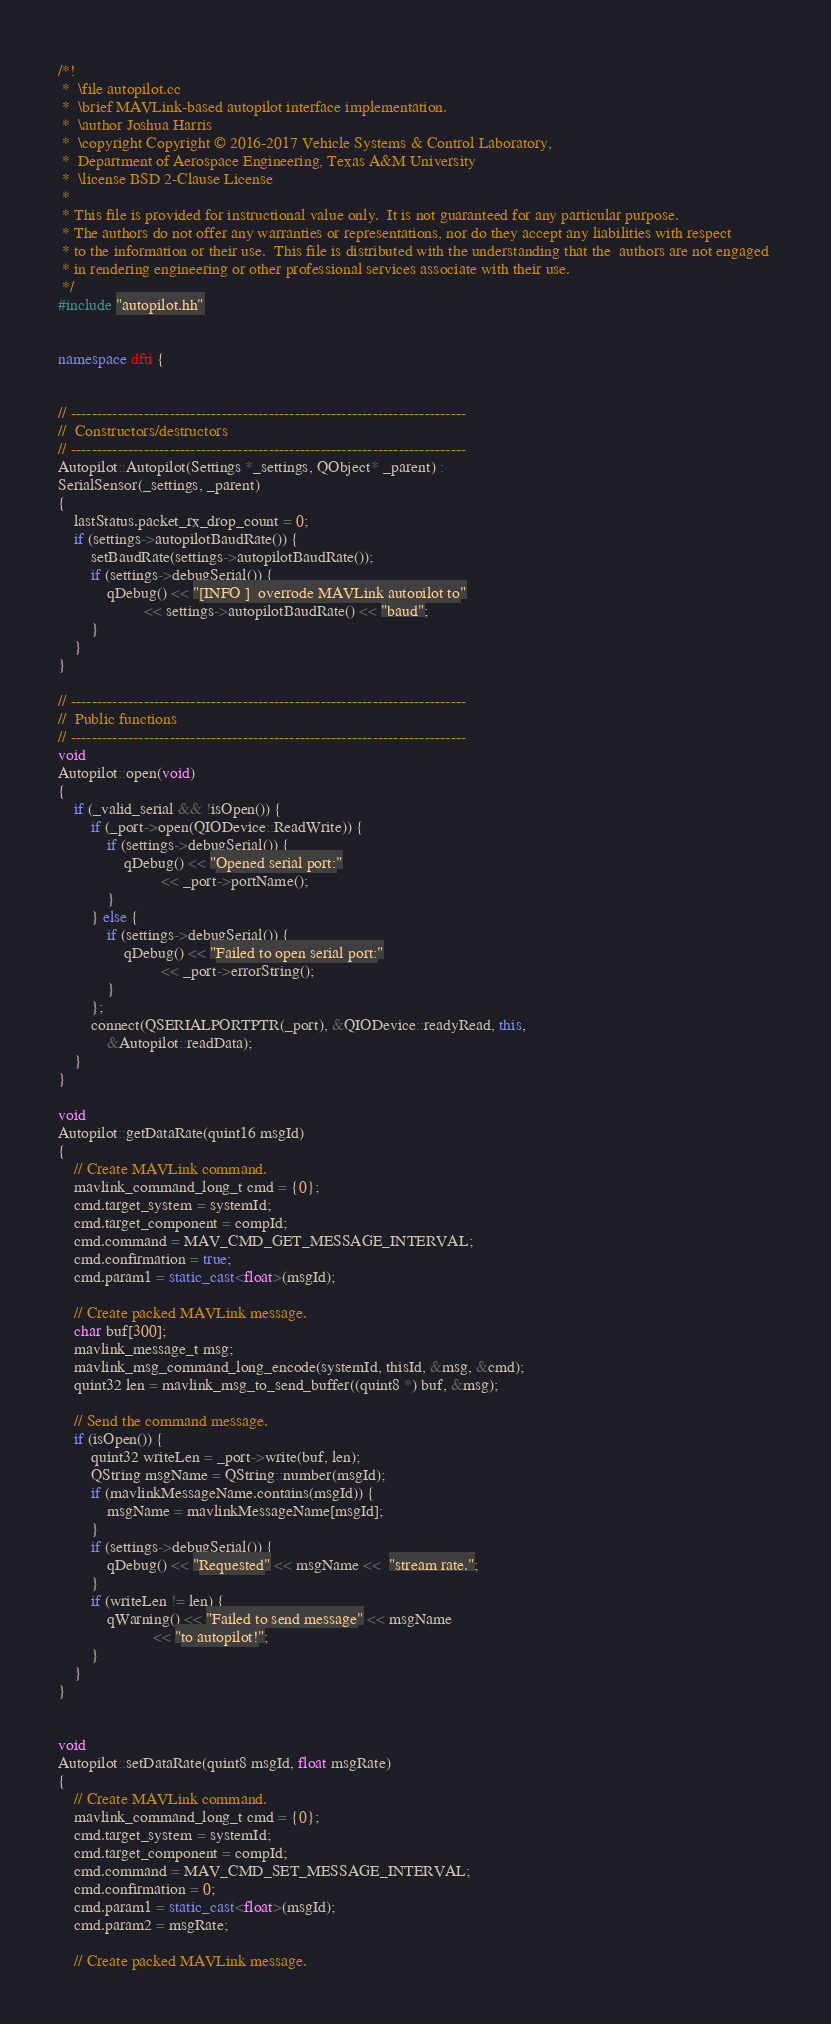Convert code to text. <code><loc_0><loc_0><loc_500><loc_500><_C++_>/*!
 *  \file autopilot.cc
 *  \brief MAVLink-based autopilot interface implementation.
 *  \author Joshua Harris
 *  \copyright Copyright © 2016-2017 Vehicle Systems & Control Laboratory,
 *  Department of Aerospace Engineering, Texas A&M University
 *  \license BSD 2-Clause License
 *
 * This file is provided for instructional value only.  It is not guaranteed for any particular purpose.  
 * The authors do not offer any warranties or representations, nor do they accept any liabilities with respect 
 * to the information or their use.  This file is distributed with the understanding that the  authors are not engaged 
 * in rendering engineering or other professional services associate with their use.
 */
#include "autopilot.hh"


namespace dfti {


// ----------------------------------------------------------------------------
//  Constructors/destructors
// ----------------------------------------------------------------------------
Autopilot::Autopilot(Settings *_settings, QObject* _parent) :
SerialSensor(_settings, _parent)
{
    lastStatus.packet_rx_drop_count = 0;
    if (settings->autopilotBaudRate()) {
        setBaudRate(settings->autopilotBaudRate());
        if (settings->debugSerial()) {
            qDebug() << "[INFO ]  overrode MAVLink autopilot to"
                     << settings->autopilotBaudRate() << "baud";
        }
    }
}

// ----------------------------------------------------------------------------
//  Public functions
// ----------------------------------------------------------------------------
void
Autopilot::open(void)
{
    if (_valid_serial && !isOpen()) {
        if (_port->open(QIODevice::ReadWrite)) {
            if (settings->debugSerial()) {
                qDebug() << "Opened serial port:"
                         << _port->portName();
            }
        } else {
            if (settings->debugSerial()) {
                qDebug() << "Failed to open serial port:"
                         << _port->errorString();
            }
        };
        connect(QSERIALPORTPTR(_port), &QIODevice::readyRead, this,
            &Autopilot::readData);
    }
}

void
Autopilot::getDataRate(quint16 msgId)
{
    // Create MAVLink command.
    mavlink_command_long_t cmd = {0};
    cmd.target_system = systemId;
    cmd.target_component = compId;
    cmd.command = MAV_CMD_GET_MESSAGE_INTERVAL;
    cmd.confirmation = true;
    cmd.param1 = static_cast<float>(msgId);

    // Create packed MAVLink message.
    char buf[300];
    mavlink_message_t msg;
    mavlink_msg_command_long_encode(systemId, thisId, &msg, &cmd);
    quint32 len = mavlink_msg_to_send_buffer((quint8 *) buf, &msg);

    // Send the command message.
    if (isOpen()) {
        quint32 writeLen = _port->write(buf, len);
        QString msgName = QString::number(msgId);
        if (mavlinkMessageName.contains(msgId)) {
            msgName = mavlinkMessageName[msgId];
        }
        if (settings->debugSerial()) {
            qDebug() << "Requested" << msgName <<  "stream rate.";
        }
        if (writeLen != len) {
            qWarning() << "Failed to send message" << msgName
                       << "to autopilot!";
        }
    }
}


void
Autopilot::setDataRate(quint8 msgId, float msgRate)
{
    // Create MAVLink command.
    mavlink_command_long_t cmd = {0};
    cmd.target_system = systemId;
    cmd.target_component = compId;
    cmd.command = MAV_CMD_SET_MESSAGE_INTERVAL;
    cmd.confirmation = 0;
    cmd.param1 = static_cast<float>(msgId);
    cmd.param2 = msgRate;

    // Create packed MAVLink message.</code> 